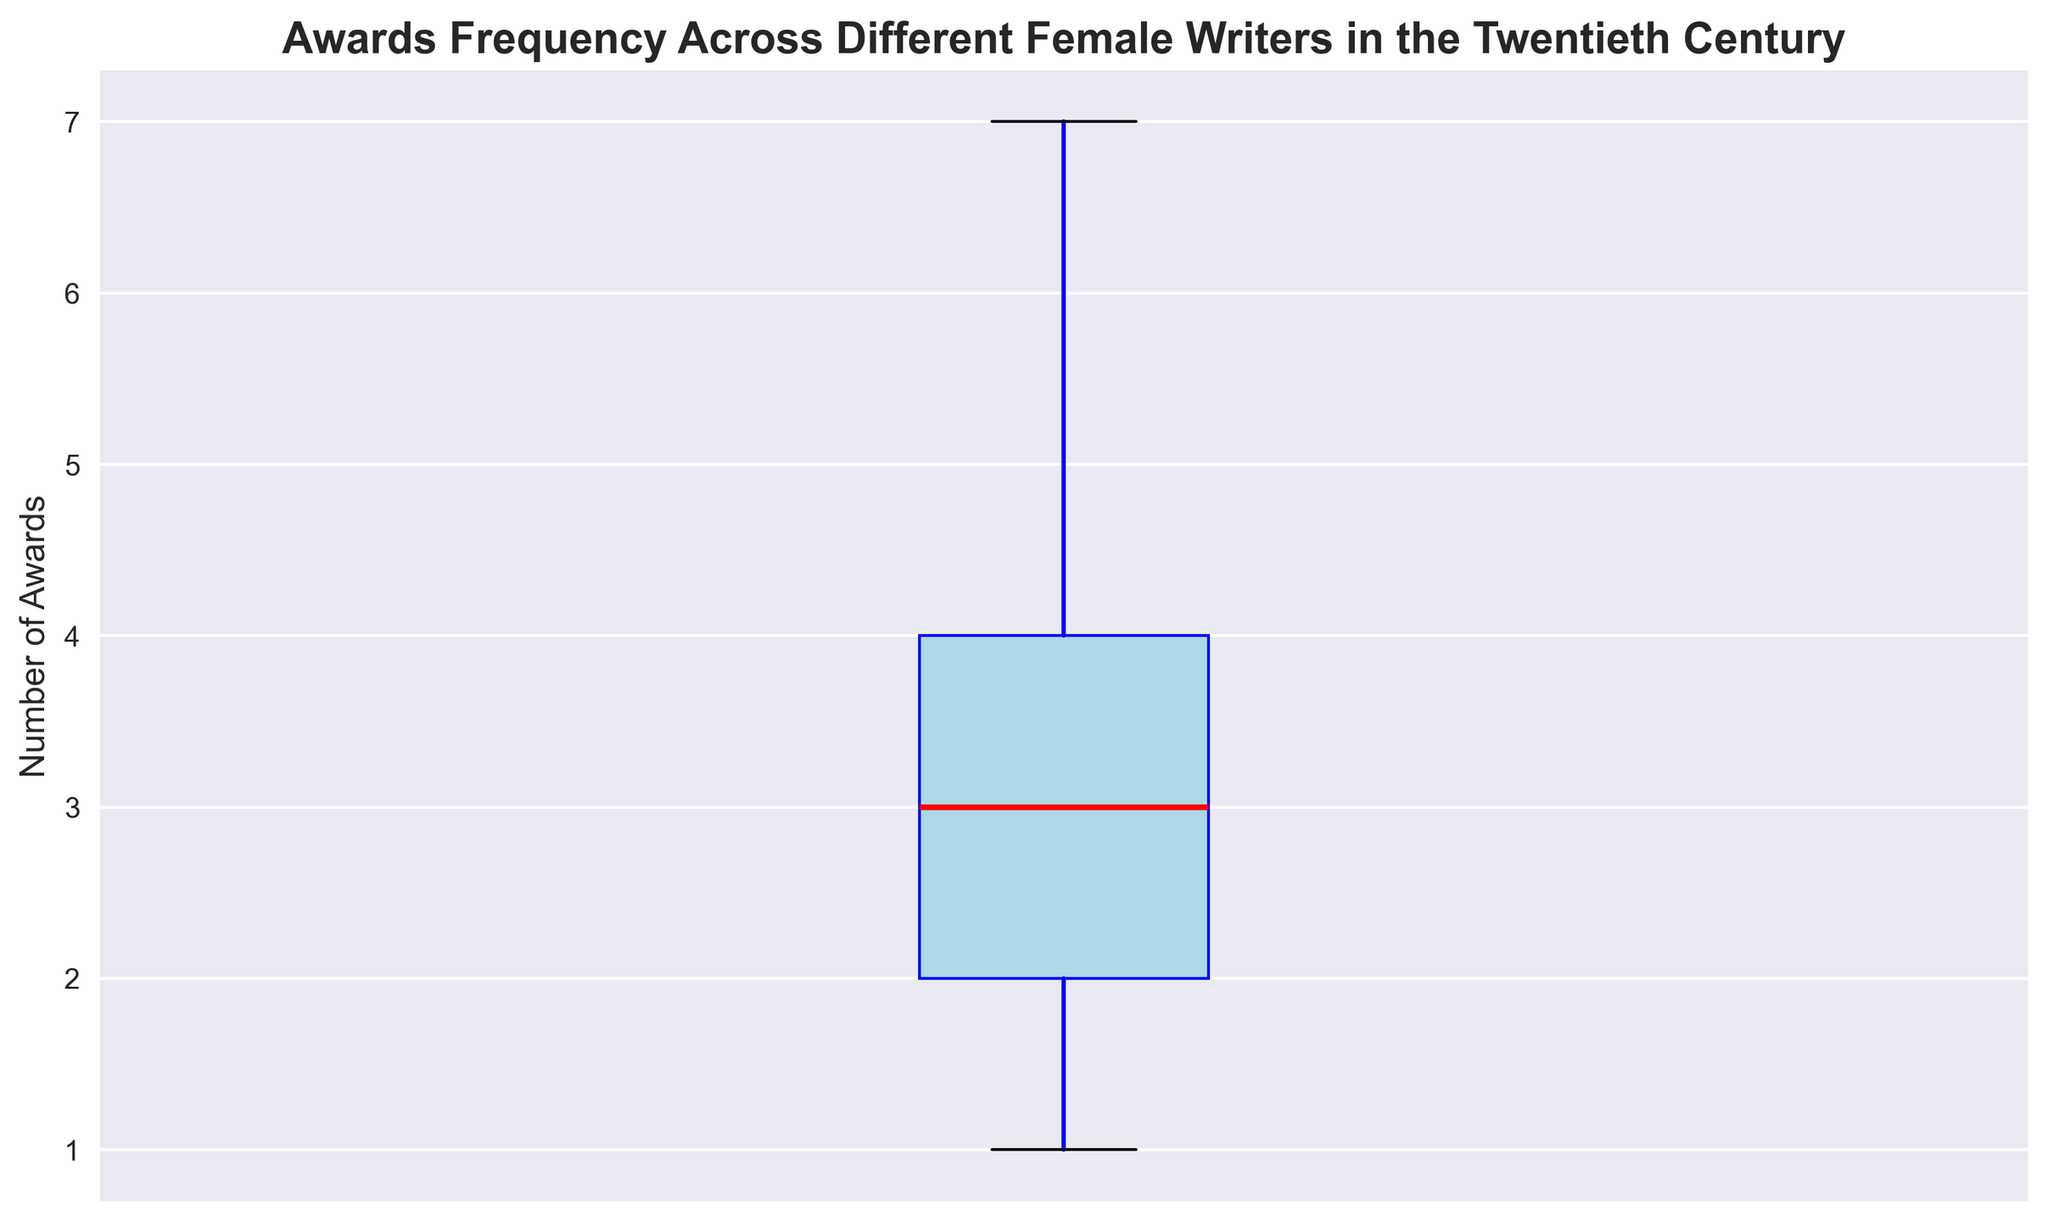What is the median number of awards won by the writers? The median is the middle value when the data is ordered. In a box plot, the median is represented by the line inside the box. The line inside the box is marked in red, indicating the median award count.
Answer: 3 Which writer has the highest number of awards, and how many awards did she win? The highest value in a box plot is represented by the upper whisker or an outlier above it. Based on the given data, the highest number of awards is 7, which is won by Agatha Christie, J.K. Rowling, and Joyce Carol Oates.
Answer: 7 What is the interquartile range of the number of awards? The interquartile range (IQR) is the difference between the third quartile (Q3) and the first quartile (Q1). In a box plot, these are represented by the top and bottom edges of the box respectively. The top edge of the box is at 5 and the bottom edge is at 2.
Answer: 3 How many awards are represented by the upper whisker in the box plot? The upper whisker represents the largest value within 1.5 times the IQR above the third quartile (Q3). In this box plot, the upper whisker extends to 6 awards.
Answer: 6 Which visual element indicates the presence of outliers, if any, and what is the outlier value? Outliers in a box plot are typically represented by individual points beyond the whiskers. In this plot, the green points indicate outliers, and the value of the outlier is 7 awards.
Answer: 7 What is the range of the central 50% of the data? The range of the central 50% of the data, also known as the IQR, is the difference between the top edge (Q3) and the bottom edge (Q1) of the box. Q3 is 5 and Q1 is 2, so the range is 5 - 2.
Answer: 3 Is the distribution of awards more skewed towards higher or lower values? The distribution skewness can be inferred by comparing the length of the whiskers and the position of the median within the box. The upper whisker is longer and the box extends further towards higher values, indicating a skew towards higher awards.
Answer: Higher What range of awards does the lower whisker cover? The lower whisker represents the smallest value within 1.5 times the IQR below the first quartile (Q1). The lower whisker extends down to 1 award.
Answer: 1 What is the maximum number of awards without considering outliers? Without considering outliers, the maximum number of awards reaches the upper edge of the whisker which is 6.
Answer: 6 